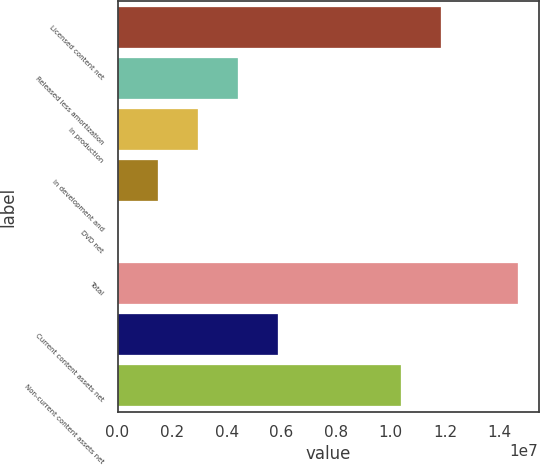Convert chart. <chart><loc_0><loc_0><loc_500><loc_500><bar_chart><fcel>Licensed content net<fcel>Released less amortization<fcel>In production<fcel>In development and<fcel>DVD net<fcel>Total<fcel>Current content assets net<fcel>Non-current content assets net<nl><fcel>1.18379e+07<fcel>4.41391e+06<fcel>2.94704e+06<fcel>1.48017e+06<fcel>13301<fcel>1.4682e+07<fcel>5.88078e+06<fcel>1.03711e+07<nl></chart> 